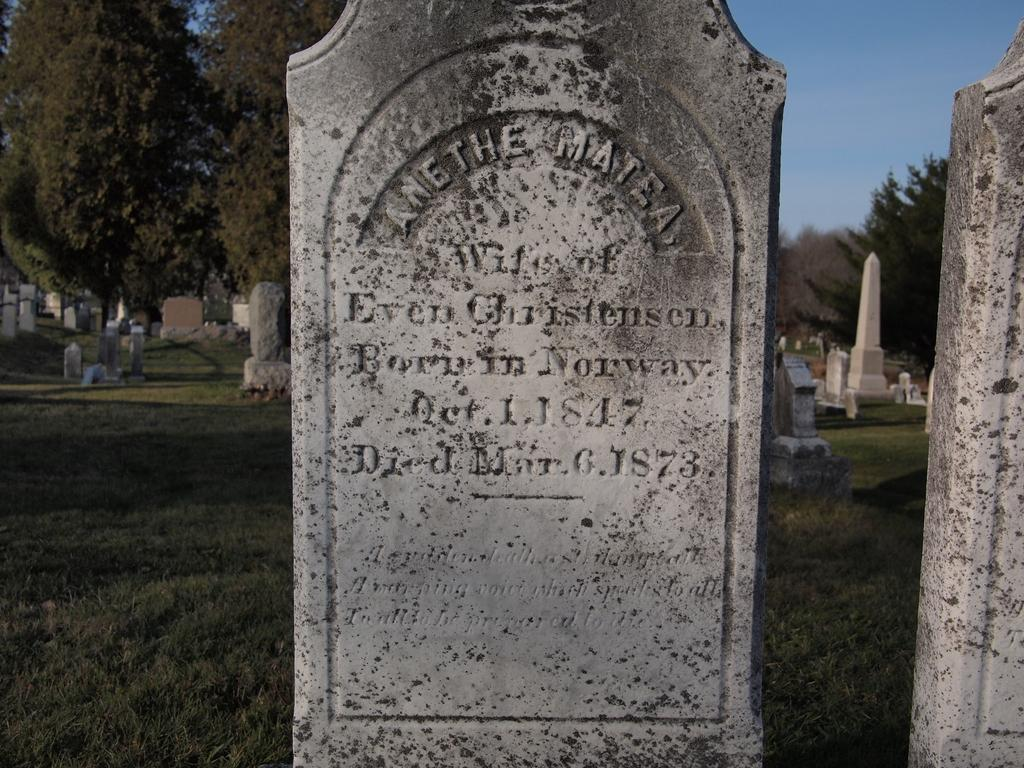What is the main setting of the image? The image depicts a graveyard. What can be seen on the stones in the graveyard? There are carvings on the stones in the graveyard. What type of vegetation is present in the graveyard? There are trees and grass on the ground in the graveyard. What is visible in the background of the image? The sky is visible in the background of the image. What can be observed in the sky? There are clouds in the sky. What type of flag is waving in the image? There is no flag present in the image; it depicts a graveyard with carvings on stones, trees, grass, and a sky with clouds. 